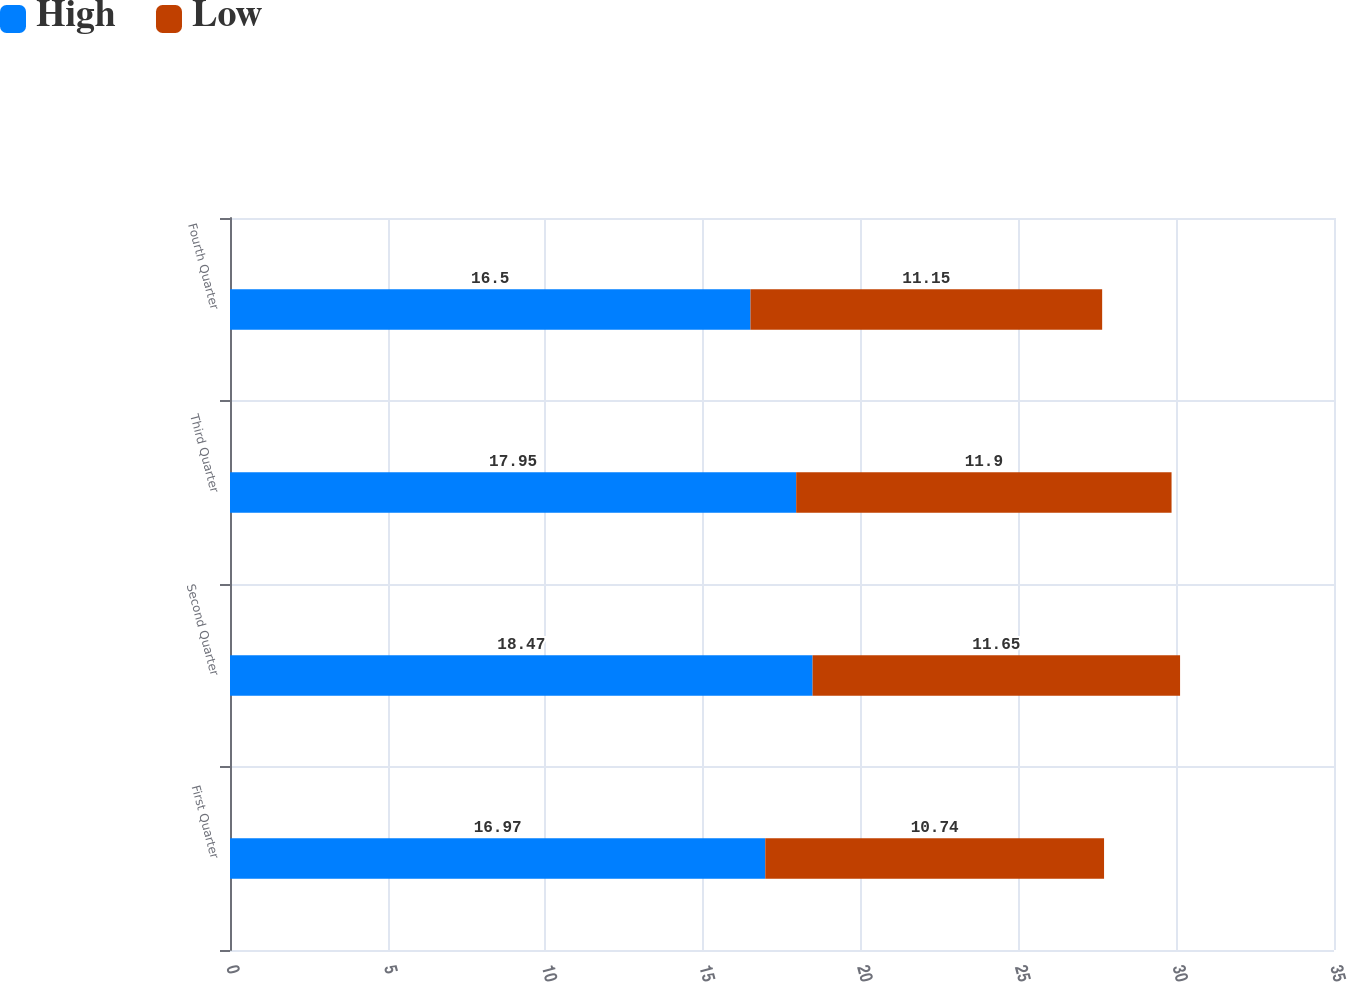<chart> <loc_0><loc_0><loc_500><loc_500><stacked_bar_chart><ecel><fcel>First Quarter<fcel>Second Quarter<fcel>Third Quarter<fcel>Fourth Quarter<nl><fcel>High<fcel>16.97<fcel>18.47<fcel>17.95<fcel>16.5<nl><fcel>Low<fcel>10.74<fcel>11.65<fcel>11.9<fcel>11.15<nl></chart> 